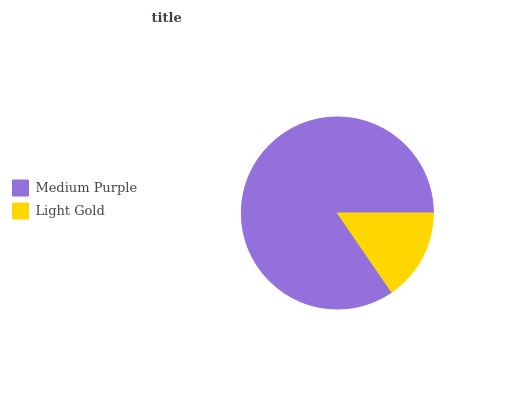Is Light Gold the minimum?
Answer yes or no. Yes. Is Medium Purple the maximum?
Answer yes or no. Yes. Is Light Gold the maximum?
Answer yes or no. No. Is Medium Purple greater than Light Gold?
Answer yes or no. Yes. Is Light Gold less than Medium Purple?
Answer yes or no. Yes. Is Light Gold greater than Medium Purple?
Answer yes or no. No. Is Medium Purple less than Light Gold?
Answer yes or no. No. Is Medium Purple the high median?
Answer yes or no. Yes. Is Light Gold the low median?
Answer yes or no. Yes. Is Light Gold the high median?
Answer yes or no. No. Is Medium Purple the low median?
Answer yes or no. No. 